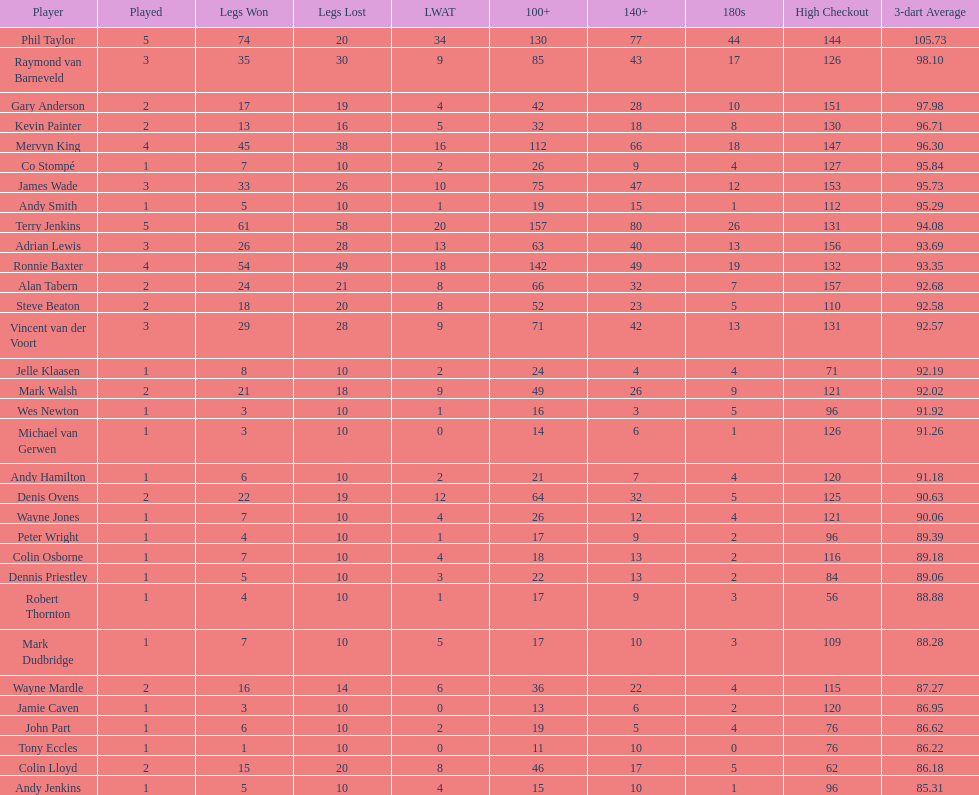Help me parse the entirety of this table. {'header': ['Player', 'Played', 'Legs Won', 'Legs Lost', 'LWAT', '100+', '140+', '180s', 'High Checkout', '3-dart Average'], 'rows': [['Phil Taylor', '5', '74', '20', '34', '130', '77', '44', '144', '105.73'], ['Raymond van Barneveld', '3', '35', '30', '9', '85', '43', '17', '126', '98.10'], ['Gary Anderson', '2', '17', '19', '4', '42', '28', '10', '151', '97.98'], ['Kevin Painter', '2', '13', '16', '5', '32', '18', '8', '130', '96.71'], ['Mervyn King', '4', '45', '38', '16', '112', '66', '18', '147', '96.30'], ['Co Stompé', '1', '7', '10', '2', '26', '9', '4', '127', '95.84'], ['James Wade', '3', '33', '26', '10', '75', '47', '12', '153', '95.73'], ['Andy Smith', '1', '5', '10', '1', '19', '15', '1', '112', '95.29'], ['Terry Jenkins', '5', '61', '58', '20', '157', '80', '26', '131', '94.08'], ['Adrian Lewis', '3', '26', '28', '13', '63', '40', '13', '156', '93.69'], ['Ronnie Baxter', '4', '54', '49', '18', '142', '49', '19', '132', '93.35'], ['Alan Tabern', '2', '24', '21', '8', '66', '32', '7', '157', '92.68'], ['Steve Beaton', '2', '18', '20', '8', '52', '23', '5', '110', '92.58'], ['Vincent van der Voort', '3', '29', '28', '9', '71', '42', '13', '131', '92.57'], ['Jelle Klaasen', '1', '8', '10', '2', '24', '4', '4', '71', '92.19'], ['Mark Walsh', '2', '21', '18', '9', '49', '26', '9', '121', '92.02'], ['Wes Newton', '1', '3', '10', '1', '16', '3', '5', '96', '91.92'], ['Michael van Gerwen', '1', '3', '10', '0', '14', '6', '1', '126', '91.26'], ['Andy Hamilton', '1', '6', '10', '2', '21', '7', '4', '120', '91.18'], ['Denis Ovens', '2', '22', '19', '12', '64', '32', '5', '125', '90.63'], ['Wayne Jones', '1', '7', '10', '4', '26', '12', '4', '121', '90.06'], ['Peter Wright', '1', '4', '10', '1', '17', '9', '2', '96', '89.39'], ['Colin Osborne', '1', '7', '10', '4', '18', '13', '2', '116', '89.18'], ['Dennis Priestley', '1', '5', '10', '3', '22', '13', '2', '84', '89.06'], ['Robert Thornton', '1', '4', '10', '1', '17', '9', '3', '56', '88.88'], ['Mark Dudbridge', '1', '7', '10', '5', '17', '10', '3', '109', '88.28'], ['Wayne Mardle', '2', '16', '14', '6', '36', '22', '4', '115', '87.27'], ['Jamie Caven', '1', '3', '10', '0', '13', '6', '2', '120', '86.95'], ['John Part', '1', '6', '10', '2', '19', '5', '4', '76', '86.62'], ['Tony Eccles', '1', '1', '10', '0', '11', '10', '0', '76', '86.22'], ['Colin Lloyd', '2', '15', '20', '8', '46', '17', '5', '62', '86.18'], ['Andy Jenkins', '1', '5', '10', '4', '15', '10', '1', '96', '85.31']]} What are the number of legs lost by james wade? 26. 